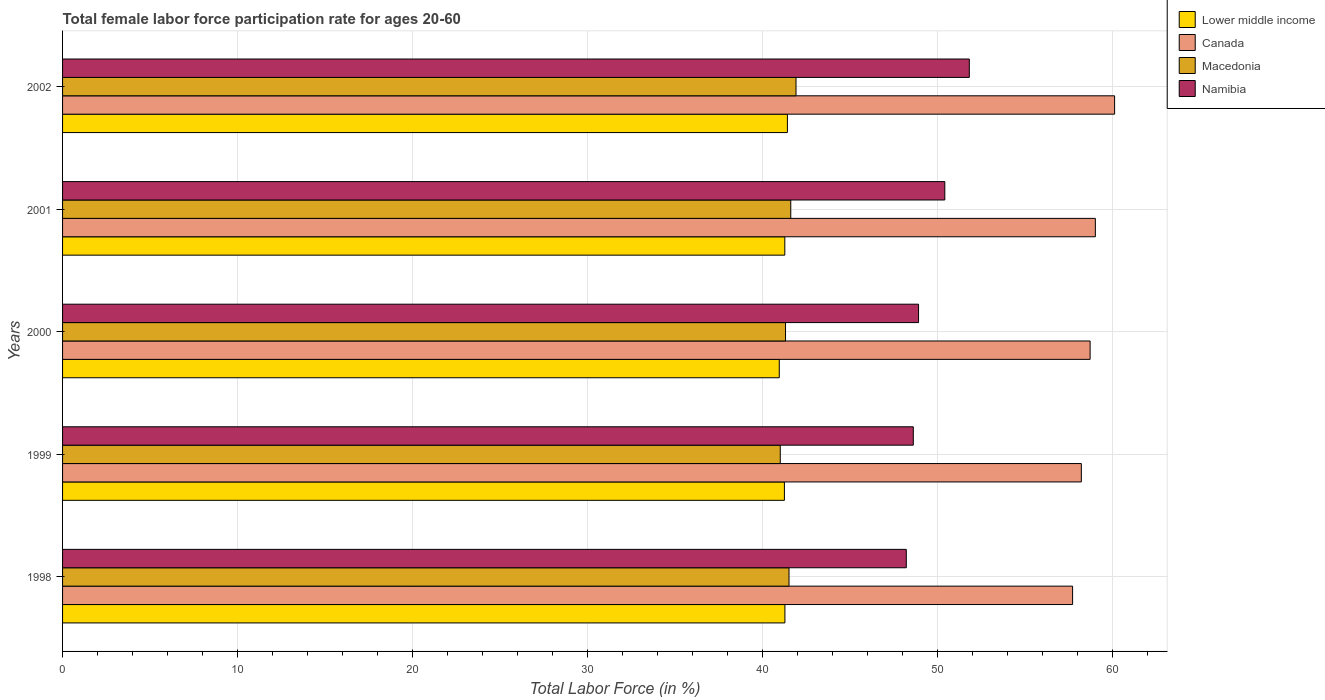How many different coloured bars are there?
Keep it short and to the point. 4. How many bars are there on the 5th tick from the top?
Provide a short and direct response. 4. How many bars are there on the 3rd tick from the bottom?
Ensure brevity in your answer.  4. What is the label of the 4th group of bars from the top?
Provide a short and direct response. 1999. In how many cases, is the number of bars for a given year not equal to the number of legend labels?
Your answer should be compact. 0. What is the female labor force participation rate in Macedonia in 1998?
Give a very brief answer. 41.5. Across all years, what is the maximum female labor force participation rate in Canada?
Ensure brevity in your answer.  60.1. Across all years, what is the minimum female labor force participation rate in Namibia?
Offer a very short reply. 48.2. What is the total female labor force participation rate in Lower middle income in the graph?
Keep it short and to the point. 206.11. What is the difference between the female labor force participation rate in Namibia in 1999 and that in 2000?
Provide a succinct answer. -0.3. What is the difference between the female labor force participation rate in Lower middle income in 2001 and the female labor force participation rate in Canada in 2002?
Provide a short and direct response. -18.84. What is the average female labor force participation rate in Macedonia per year?
Offer a very short reply. 41.46. In the year 1999, what is the difference between the female labor force participation rate in Canada and female labor force participation rate in Macedonia?
Keep it short and to the point. 17.2. In how many years, is the female labor force participation rate in Canada greater than 48 %?
Your response must be concise. 5. What is the ratio of the female labor force participation rate in Macedonia in 1998 to that in 2002?
Your answer should be very brief. 0.99. Is the difference between the female labor force participation rate in Canada in 1999 and 2001 greater than the difference between the female labor force participation rate in Macedonia in 1999 and 2001?
Ensure brevity in your answer.  No. What is the difference between the highest and the second highest female labor force participation rate in Namibia?
Your answer should be very brief. 1.4. What is the difference between the highest and the lowest female labor force participation rate in Namibia?
Offer a very short reply. 3.6. In how many years, is the female labor force participation rate in Canada greater than the average female labor force participation rate in Canada taken over all years?
Your answer should be very brief. 2. Is the sum of the female labor force participation rate in Lower middle income in 1998 and 2002 greater than the maximum female labor force participation rate in Namibia across all years?
Offer a terse response. Yes. Is it the case that in every year, the sum of the female labor force participation rate in Macedonia and female labor force participation rate in Namibia is greater than the sum of female labor force participation rate in Lower middle income and female labor force participation rate in Canada?
Make the answer very short. Yes. What does the 2nd bar from the top in 1998 represents?
Your answer should be compact. Macedonia. What does the 3rd bar from the bottom in 2002 represents?
Provide a succinct answer. Macedonia. Are all the bars in the graph horizontal?
Your answer should be very brief. Yes. How many years are there in the graph?
Offer a terse response. 5. What is the difference between two consecutive major ticks on the X-axis?
Keep it short and to the point. 10. Does the graph contain any zero values?
Provide a succinct answer. No. Where does the legend appear in the graph?
Give a very brief answer. Top right. What is the title of the graph?
Your answer should be very brief. Total female labor force participation rate for ages 20-60. Does "Jamaica" appear as one of the legend labels in the graph?
Make the answer very short. No. What is the label or title of the X-axis?
Provide a short and direct response. Total Labor Force (in %). What is the label or title of the Y-axis?
Offer a very short reply. Years. What is the Total Labor Force (in %) of Lower middle income in 1998?
Provide a succinct answer. 41.27. What is the Total Labor Force (in %) in Canada in 1998?
Give a very brief answer. 57.7. What is the Total Labor Force (in %) in Macedonia in 1998?
Offer a terse response. 41.5. What is the Total Labor Force (in %) of Namibia in 1998?
Provide a succinct answer. 48.2. What is the Total Labor Force (in %) in Lower middle income in 1999?
Keep it short and to the point. 41.24. What is the Total Labor Force (in %) in Canada in 1999?
Your answer should be very brief. 58.2. What is the Total Labor Force (in %) in Macedonia in 1999?
Keep it short and to the point. 41. What is the Total Labor Force (in %) of Namibia in 1999?
Give a very brief answer. 48.6. What is the Total Labor Force (in %) of Lower middle income in 2000?
Offer a very short reply. 40.94. What is the Total Labor Force (in %) in Canada in 2000?
Provide a succinct answer. 58.7. What is the Total Labor Force (in %) in Macedonia in 2000?
Give a very brief answer. 41.3. What is the Total Labor Force (in %) in Namibia in 2000?
Offer a terse response. 48.9. What is the Total Labor Force (in %) in Lower middle income in 2001?
Keep it short and to the point. 41.26. What is the Total Labor Force (in %) of Canada in 2001?
Your response must be concise. 59. What is the Total Labor Force (in %) in Macedonia in 2001?
Make the answer very short. 41.6. What is the Total Labor Force (in %) in Namibia in 2001?
Your answer should be compact. 50.4. What is the Total Labor Force (in %) in Lower middle income in 2002?
Offer a very short reply. 41.41. What is the Total Labor Force (in %) of Canada in 2002?
Keep it short and to the point. 60.1. What is the Total Labor Force (in %) of Macedonia in 2002?
Provide a short and direct response. 41.9. What is the Total Labor Force (in %) in Namibia in 2002?
Ensure brevity in your answer.  51.8. Across all years, what is the maximum Total Labor Force (in %) of Lower middle income?
Offer a terse response. 41.41. Across all years, what is the maximum Total Labor Force (in %) of Canada?
Make the answer very short. 60.1. Across all years, what is the maximum Total Labor Force (in %) in Macedonia?
Make the answer very short. 41.9. Across all years, what is the maximum Total Labor Force (in %) of Namibia?
Provide a succinct answer. 51.8. Across all years, what is the minimum Total Labor Force (in %) of Lower middle income?
Keep it short and to the point. 40.94. Across all years, what is the minimum Total Labor Force (in %) of Canada?
Ensure brevity in your answer.  57.7. Across all years, what is the minimum Total Labor Force (in %) of Macedonia?
Keep it short and to the point. 41. Across all years, what is the minimum Total Labor Force (in %) in Namibia?
Your answer should be compact. 48.2. What is the total Total Labor Force (in %) in Lower middle income in the graph?
Your answer should be very brief. 206.11. What is the total Total Labor Force (in %) of Canada in the graph?
Make the answer very short. 293.7. What is the total Total Labor Force (in %) in Macedonia in the graph?
Provide a succinct answer. 207.3. What is the total Total Labor Force (in %) in Namibia in the graph?
Your response must be concise. 247.9. What is the difference between the Total Labor Force (in %) of Canada in 1998 and that in 1999?
Your answer should be compact. -0.5. What is the difference between the Total Labor Force (in %) of Macedonia in 1998 and that in 1999?
Make the answer very short. 0.5. What is the difference between the Total Labor Force (in %) in Lower middle income in 1998 and that in 2000?
Provide a succinct answer. 0.32. What is the difference between the Total Labor Force (in %) of Canada in 1998 and that in 2000?
Keep it short and to the point. -1. What is the difference between the Total Labor Force (in %) of Macedonia in 1998 and that in 2000?
Make the answer very short. 0.2. What is the difference between the Total Labor Force (in %) in Namibia in 1998 and that in 2000?
Offer a very short reply. -0.7. What is the difference between the Total Labor Force (in %) in Lower middle income in 1998 and that in 2001?
Make the answer very short. 0.01. What is the difference between the Total Labor Force (in %) in Canada in 1998 and that in 2001?
Your response must be concise. -1.3. What is the difference between the Total Labor Force (in %) in Macedonia in 1998 and that in 2001?
Your answer should be very brief. -0.1. What is the difference between the Total Labor Force (in %) in Lower middle income in 1998 and that in 2002?
Ensure brevity in your answer.  -0.14. What is the difference between the Total Labor Force (in %) in Lower middle income in 1999 and that in 2000?
Ensure brevity in your answer.  0.29. What is the difference between the Total Labor Force (in %) in Namibia in 1999 and that in 2000?
Offer a terse response. -0.3. What is the difference between the Total Labor Force (in %) of Lower middle income in 1999 and that in 2001?
Provide a short and direct response. -0.02. What is the difference between the Total Labor Force (in %) in Canada in 1999 and that in 2001?
Provide a succinct answer. -0.8. What is the difference between the Total Labor Force (in %) in Macedonia in 1999 and that in 2001?
Give a very brief answer. -0.6. What is the difference between the Total Labor Force (in %) in Lower middle income in 1999 and that in 2002?
Give a very brief answer. -0.17. What is the difference between the Total Labor Force (in %) in Macedonia in 1999 and that in 2002?
Your answer should be compact. -0.9. What is the difference between the Total Labor Force (in %) in Namibia in 1999 and that in 2002?
Provide a succinct answer. -3.2. What is the difference between the Total Labor Force (in %) in Lower middle income in 2000 and that in 2001?
Provide a short and direct response. -0.32. What is the difference between the Total Labor Force (in %) in Macedonia in 2000 and that in 2001?
Provide a succinct answer. -0.3. What is the difference between the Total Labor Force (in %) in Lower middle income in 2000 and that in 2002?
Your response must be concise. -0.47. What is the difference between the Total Labor Force (in %) in Canada in 2000 and that in 2002?
Your answer should be very brief. -1.4. What is the difference between the Total Labor Force (in %) of Macedonia in 2000 and that in 2002?
Give a very brief answer. -0.6. What is the difference between the Total Labor Force (in %) of Namibia in 2000 and that in 2002?
Offer a very short reply. -2.9. What is the difference between the Total Labor Force (in %) of Lower middle income in 2001 and that in 2002?
Your answer should be compact. -0.15. What is the difference between the Total Labor Force (in %) in Canada in 2001 and that in 2002?
Make the answer very short. -1.1. What is the difference between the Total Labor Force (in %) of Lower middle income in 1998 and the Total Labor Force (in %) of Canada in 1999?
Offer a terse response. -16.93. What is the difference between the Total Labor Force (in %) of Lower middle income in 1998 and the Total Labor Force (in %) of Macedonia in 1999?
Ensure brevity in your answer.  0.27. What is the difference between the Total Labor Force (in %) of Lower middle income in 1998 and the Total Labor Force (in %) of Namibia in 1999?
Give a very brief answer. -7.33. What is the difference between the Total Labor Force (in %) in Canada in 1998 and the Total Labor Force (in %) in Macedonia in 1999?
Provide a succinct answer. 16.7. What is the difference between the Total Labor Force (in %) in Macedonia in 1998 and the Total Labor Force (in %) in Namibia in 1999?
Give a very brief answer. -7.1. What is the difference between the Total Labor Force (in %) of Lower middle income in 1998 and the Total Labor Force (in %) of Canada in 2000?
Offer a very short reply. -17.43. What is the difference between the Total Labor Force (in %) in Lower middle income in 1998 and the Total Labor Force (in %) in Macedonia in 2000?
Your response must be concise. -0.03. What is the difference between the Total Labor Force (in %) in Lower middle income in 1998 and the Total Labor Force (in %) in Namibia in 2000?
Your answer should be compact. -7.63. What is the difference between the Total Labor Force (in %) in Canada in 1998 and the Total Labor Force (in %) in Namibia in 2000?
Provide a short and direct response. 8.8. What is the difference between the Total Labor Force (in %) of Macedonia in 1998 and the Total Labor Force (in %) of Namibia in 2000?
Provide a succinct answer. -7.4. What is the difference between the Total Labor Force (in %) of Lower middle income in 1998 and the Total Labor Force (in %) of Canada in 2001?
Provide a short and direct response. -17.73. What is the difference between the Total Labor Force (in %) in Lower middle income in 1998 and the Total Labor Force (in %) in Macedonia in 2001?
Keep it short and to the point. -0.33. What is the difference between the Total Labor Force (in %) in Lower middle income in 1998 and the Total Labor Force (in %) in Namibia in 2001?
Offer a very short reply. -9.13. What is the difference between the Total Labor Force (in %) in Canada in 1998 and the Total Labor Force (in %) in Namibia in 2001?
Keep it short and to the point. 7.3. What is the difference between the Total Labor Force (in %) of Lower middle income in 1998 and the Total Labor Force (in %) of Canada in 2002?
Provide a short and direct response. -18.83. What is the difference between the Total Labor Force (in %) of Lower middle income in 1998 and the Total Labor Force (in %) of Macedonia in 2002?
Ensure brevity in your answer.  -0.63. What is the difference between the Total Labor Force (in %) of Lower middle income in 1998 and the Total Labor Force (in %) of Namibia in 2002?
Provide a succinct answer. -10.53. What is the difference between the Total Labor Force (in %) of Macedonia in 1998 and the Total Labor Force (in %) of Namibia in 2002?
Offer a terse response. -10.3. What is the difference between the Total Labor Force (in %) of Lower middle income in 1999 and the Total Labor Force (in %) of Canada in 2000?
Provide a short and direct response. -17.46. What is the difference between the Total Labor Force (in %) of Lower middle income in 1999 and the Total Labor Force (in %) of Macedonia in 2000?
Your response must be concise. -0.06. What is the difference between the Total Labor Force (in %) of Lower middle income in 1999 and the Total Labor Force (in %) of Namibia in 2000?
Provide a short and direct response. -7.66. What is the difference between the Total Labor Force (in %) of Canada in 1999 and the Total Labor Force (in %) of Macedonia in 2000?
Ensure brevity in your answer.  16.9. What is the difference between the Total Labor Force (in %) in Canada in 1999 and the Total Labor Force (in %) in Namibia in 2000?
Make the answer very short. 9.3. What is the difference between the Total Labor Force (in %) of Lower middle income in 1999 and the Total Labor Force (in %) of Canada in 2001?
Make the answer very short. -17.76. What is the difference between the Total Labor Force (in %) of Lower middle income in 1999 and the Total Labor Force (in %) of Macedonia in 2001?
Provide a short and direct response. -0.36. What is the difference between the Total Labor Force (in %) in Lower middle income in 1999 and the Total Labor Force (in %) in Namibia in 2001?
Keep it short and to the point. -9.16. What is the difference between the Total Labor Force (in %) in Canada in 1999 and the Total Labor Force (in %) in Macedonia in 2001?
Provide a short and direct response. 16.6. What is the difference between the Total Labor Force (in %) of Macedonia in 1999 and the Total Labor Force (in %) of Namibia in 2001?
Keep it short and to the point. -9.4. What is the difference between the Total Labor Force (in %) of Lower middle income in 1999 and the Total Labor Force (in %) of Canada in 2002?
Offer a very short reply. -18.86. What is the difference between the Total Labor Force (in %) of Lower middle income in 1999 and the Total Labor Force (in %) of Macedonia in 2002?
Give a very brief answer. -0.66. What is the difference between the Total Labor Force (in %) of Lower middle income in 1999 and the Total Labor Force (in %) of Namibia in 2002?
Make the answer very short. -10.56. What is the difference between the Total Labor Force (in %) of Canada in 1999 and the Total Labor Force (in %) of Macedonia in 2002?
Your response must be concise. 16.3. What is the difference between the Total Labor Force (in %) of Macedonia in 1999 and the Total Labor Force (in %) of Namibia in 2002?
Your answer should be very brief. -10.8. What is the difference between the Total Labor Force (in %) in Lower middle income in 2000 and the Total Labor Force (in %) in Canada in 2001?
Your answer should be compact. -18.06. What is the difference between the Total Labor Force (in %) in Lower middle income in 2000 and the Total Labor Force (in %) in Macedonia in 2001?
Your response must be concise. -0.66. What is the difference between the Total Labor Force (in %) in Lower middle income in 2000 and the Total Labor Force (in %) in Namibia in 2001?
Offer a terse response. -9.46. What is the difference between the Total Labor Force (in %) of Lower middle income in 2000 and the Total Labor Force (in %) of Canada in 2002?
Offer a terse response. -19.16. What is the difference between the Total Labor Force (in %) in Lower middle income in 2000 and the Total Labor Force (in %) in Macedonia in 2002?
Make the answer very short. -0.96. What is the difference between the Total Labor Force (in %) in Lower middle income in 2000 and the Total Labor Force (in %) in Namibia in 2002?
Your answer should be compact. -10.86. What is the difference between the Total Labor Force (in %) of Canada in 2000 and the Total Labor Force (in %) of Macedonia in 2002?
Provide a short and direct response. 16.8. What is the difference between the Total Labor Force (in %) in Macedonia in 2000 and the Total Labor Force (in %) in Namibia in 2002?
Ensure brevity in your answer.  -10.5. What is the difference between the Total Labor Force (in %) in Lower middle income in 2001 and the Total Labor Force (in %) in Canada in 2002?
Provide a succinct answer. -18.84. What is the difference between the Total Labor Force (in %) of Lower middle income in 2001 and the Total Labor Force (in %) of Macedonia in 2002?
Your answer should be compact. -0.64. What is the difference between the Total Labor Force (in %) in Lower middle income in 2001 and the Total Labor Force (in %) in Namibia in 2002?
Ensure brevity in your answer.  -10.54. What is the difference between the Total Labor Force (in %) of Canada in 2001 and the Total Labor Force (in %) of Namibia in 2002?
Your answer should be compact. 7.2. What is the average Total Labor Force (in %) in Lower middle income per year?
Make the answer very short. 41.22. What is the average Total Labor Force (in %) in Canada per year?
Keep it short and to the point. 58.74. What is the average Total Labor Force (in %) in Macedonia per year?
Your response must be concise. 41.46. What is the average Total Labor Force (in %) of Namibia per year?
Give a very brief answer. 49.58. In the year 1998, what is the difference between the Total Labor Force (in %) in Lower middle income and Total Labor Force (in %) in Canada?
Provide a succinct answer. -16.43. In the year 1998, what is the difference between the Total Labor Force (in %) of Lower middle income and Total Labor Force (in %) of Macedonia?
Your answer should be very brief. -0.23. In the year 1998, what is the difference between the Total Labor Force (in %) of Lower middle income and Total Labor Force (in %) of Namibia?
Your answer should be compact. -6.93. In the year 1998, what is the difference between the Total Labor Force (in %) of Canada and Total Labor Force (in %) of Namibia?
Your answer should be very brief. 9.5. In the year 1999, what is the difference between the Total Labor Force (in %) of Lower middle income and Total Labor Force (in %) of Canada?
Offer a very short reply. -16.96. In the year 1999, what is the difference between the Total Labor Force (in %) in Lower middle income and Total Labor Force (in %) in Macedonia?
Your answer should be compact. 0.24. In the year 1999, what is the difference between the Total Labor Force (in %) of Lower middle income and Total Labor Force (in %) of Namibia?
Offer a very short reply. -7.36. In the year 1999, what is the difference between the Total Labor Force (in %) of Canada and Total Labor Force (in %) of Namibia?
Your answer should be very brief. 9.6. In the year 1999, what is the difference between the Total Labor Force (in %) in Macedonia and Total Labor Force (in %) in Namibia?
Offer a very short reply. -7.6. In the year 2000, what is the difference between the Total Labor Force (in %) in Lower middle income and Total Labor Force (in %) in Canada?
Ensure brevity in your answer.  -17.76. In the year 2000, what is the difference between the Total Labor Force (in %) in Lower middle income and Total Labor Force (in %) in Macedonia?
Your response must be concise. -0.36. In the year 2000, what is the difference between the Total Labor Force (in %) of Lower middle income and Total Labor Force (in %) of Namibia?
Your answer should be compact. -7.96. In the year 2000, what is the difference between the Total Labor Force (in %) of Canada and Total Labor Force (in %) of Namibia?
Provide a short and direct response. 9.8. In the year 2001, what is the difference between the Total Labor Force (in %) in Lower middle income and Total Labor Force (in %) in Canada?
Keep it short and to the point. -17.74. In the year 2001, what is the difference between the Total Labor Force (in %) of Lower middle income and Total Labor Force (in %) of Macedonia?
Your answer should be very brief. -0.34. In the year 2001, what is the difference between the Total Labor Force (in %) in Lower middle income and Total Labor Force (in %) in Namibia?
Offer a very short reply. -9.14. In the year 2001, what is the difference between the Total Labor Force (in %) of Canada and Total Labor Force (in %) of Macedonia?
Offer a very short reply. 17.4. In the year 2001, what is the difference between the Total Labor Force (in %) in Canada and Total Labor Force (in %) in Namibia?
Give a very brief answer. 8.6. In the year 2002, what is the difference between the Total Labor Force (in %) of Lower middle income and Total Labor Force (in %) of Canada?
Provide a succinct answer. -18.69. In the year 2002, what is the difference between the Total Labor Force (in %) of Lower middle income and Total Labor Force (in %) of Macedonia?
Offer a very short reply. -0.49. In the year 2002, what is the difference between the Total Labor Force (in %) in Lower middle income and Total Labor Force (in %) in Namibia?
Offer a terse response. -10.39. What is the ratio of the Total Labor Force (in %) in Lower middle income in 1998 to that in 1999?
Your response must be concise. 1. What is the ratio of the Total Labor Force (in %) of Macedonia in 1998 to that in 1999?
Offer a very short reply. 1.01. What is the ratio of the Total Labor Force (in %) in Namibia in 1998 to that in 1999?
Provide a short and direct response. 0.99. What is the ratio of the Total Labor Force (in %) in Lower middle income in 1998 to that in 2000?
Provide a succinct answer. 1.01. What is the ratio of the Total Labor Force (in %) in Canada in 1998 to that in 2000?
Provide a short and direct response. 0.98. What is the ratio of the Total Labor Force (in %) of Namibia in 1998 to that in 2000?
Offer a very short reply. 0.99. What is the ratio of the Total Labor Force (in %) of Lower middle income in 1998 to that in 2001?
Offer a very short reply. 1. What is the ratio of the Total Labor Force (in %) in Canada in 1998 to that in 2001?
Provide a succinct answer. 0.98. What is the ratio of the Total Labor Force (in %) in Namibia in 1998 to that in 2001?
Offer a terse response. 0.96. What is the ratio of the Total Labor Force (in %) of Canada in 1998 to that in 2002?
Make the answer very short. 0.96. What is the ratio of the Total Labor Force (in %) of Namibia in 1998 to that in 2002?
Your response must be concise. 0.93. What is the ratio of the Total Labor Force (in %) in Namibia in 1999 to that in 2000?
Provide a succinct answer. 0.99. What is the ratio of the Total Labor Force (in %) of Canada in 1999 to that in 2001?
Offer a very short reply. 0.99. What is the ratio of the Total Labor Force (in %) of Macedonia in 1999 to that in 2001?
Your response must be concise. 0.99. What is the ratio of the Total Labor Force (in %) of Canada in 1999 to that in 2002?
Your response must be concise. 0.97. What is the ratio of the Total Labor Force (in %) of Macedonia in 1999 to that in 2002?
Provide a succinct answer. 0.98. What is the ratio of the Total Labor Force (in %) in Namibia in 1999 to that in 2002?
Your answer should be very brief. 0.94. What is the ratio of the Total Labor Force (in %) in Canada in 2000 to that in 2001?
Your answer should be very brief. 0.99. What is the ratio of the Total Labor Force (in %) in Namibia in 2000 to that in 2001?
Make the answer very short. 0.97. What is the ratio of the Total Labor Force (in %) in Canada in 2000 to that in 2002?
Your response must be concise. 0.98. What is the ratio of the Total Labor Force (in %) of Macedonia in 2000 to that in 2002?
Your answer should be very brief. 0.99. What is the ratio of the Total Labor Force (in %) of Namibia in 2000 to that in 2002?
Your answer should be very brief. 0.94. What is the ratio of the Total Labor Force (in %) in Canada in 2001 to that in 2002?
Keep it short and to the point. 0.98. What is the ratio of the Total Labor Force (in %) in Macedonia in 2001 to that in 2002?
Ensure brevity in your answer.  0.99. What is the difference between the highest and the second highest Total Labor Force (in %) in Lower middle income?
Your answer should be very brief. 0.14. What is the difference between the highest and the lowest Total Labor Force (in %) in Lower middle income?
Give a very brief answer. 0.47. What is the difference between the highest and the lowest Total Labor Force (in %) of Canada?
Give a very brief answer. 2.4. What is the difference between the highest and the lowest Total Labor Force (in %) in Namibia?
Offer a terse response. 3.6. 